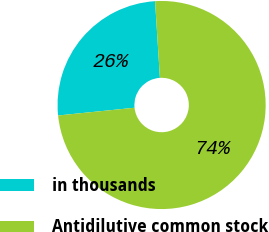Convert chart. <chart><loc_0><loc_0><loc_500><loc_500><pie_chart><fcel>in thousands<fcel>Antidilutive common stock<nl><fcel>25.6%<fcel>74.4%<nl></chart> 